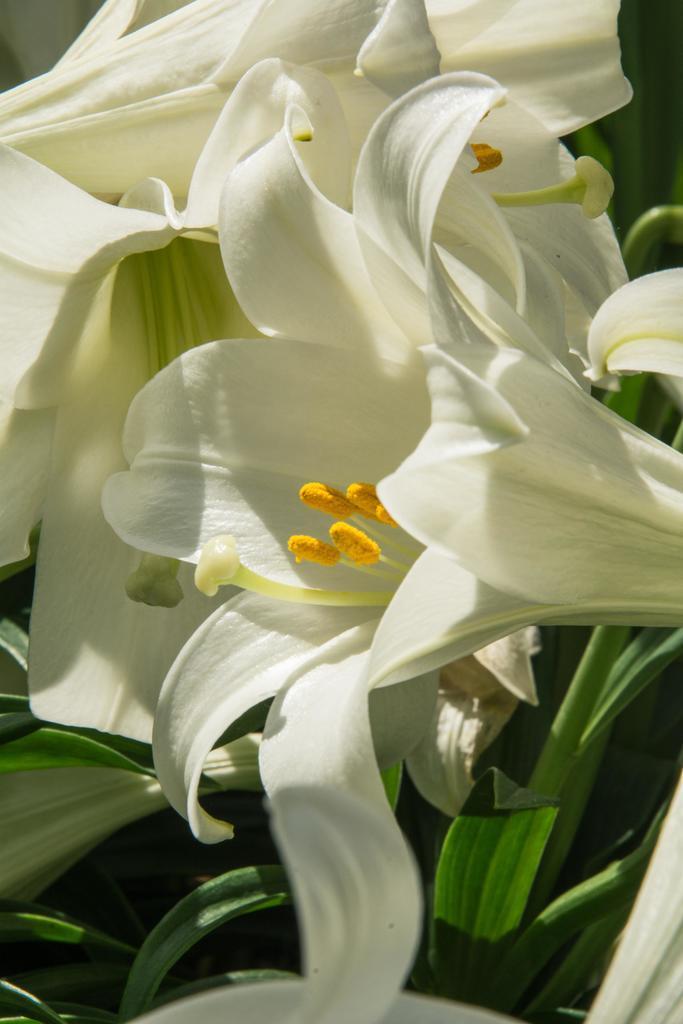In one or two sentences, can you explain what this image depicts? In this image we can see some plants with white flowers. 